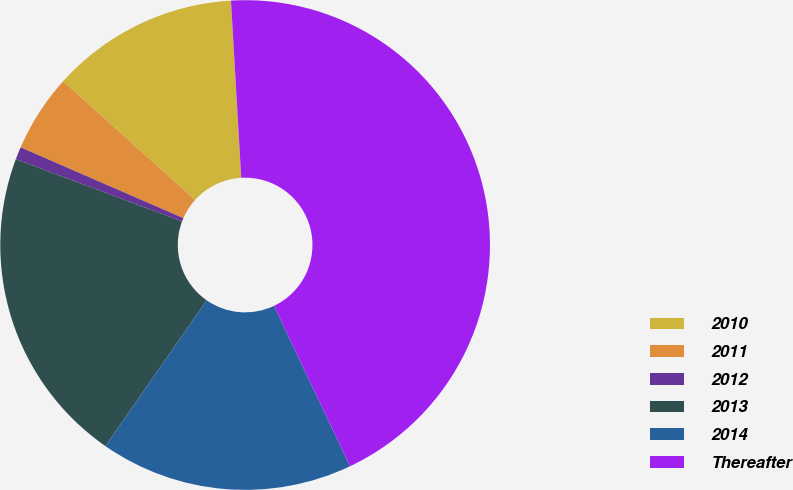Convert chart. <chart><loc_0><loc_0><loc_500><loc_500><pie_chart><fcel>2010<fcel>2011<fcel>2012<fcel>2013<fcel>2014<fcel>Thereafter<nl><fcel>12.42%<fcel>5.13%<fcel>0.83%<fcel>21.03%<fcel>16.72%<fcel>43.87%<nl></chart> 